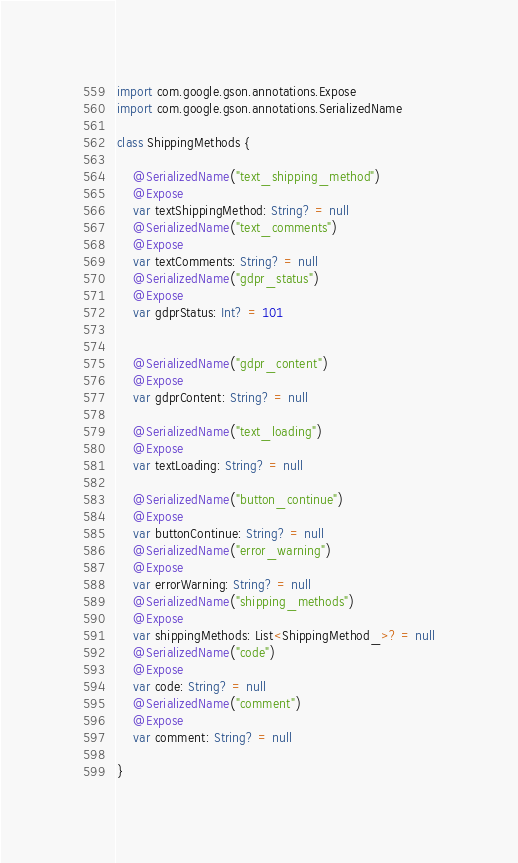Convert code to text. <code><loc_0><loc_0><loc_500><loc_500><_Kotlin_>import com.google.gson.annotations.Expose
import com.google.gson.annotations.SerializedName

class ShippingMethods {

    @SerializedName("text_shipping_method")
    @Expose
    var textShippingMethod: String? = null
    @SerializedName("text_comments")
    @Expose
    var textComments: String? = null
    @SerializedName("gdpr_status")
    @Expose
    var gdprStatus: Int? = 101


    @SerializedName("gdpr_content")
    @Expose
    var gdprContent: String? = null

    @SerializedName("text_loading")
    @Expose
    var textLoading: String? = null

    @SerializedName("button_continue")
    @Expose
    var buttonContinue: String? = null
    @SerializedName("error_warning")
    @Expose
    var errorWarning: String? = null
    @SerializedName("shipping_methods")
    @Expose
    var shippingMethods: List<ShippingMethod_>? = null
    @SerializedName("code")
    @Expose
    var code: String? = null
    @SerializedName("comment")
    @Expose
    var comment: String? = null

}
</code> 